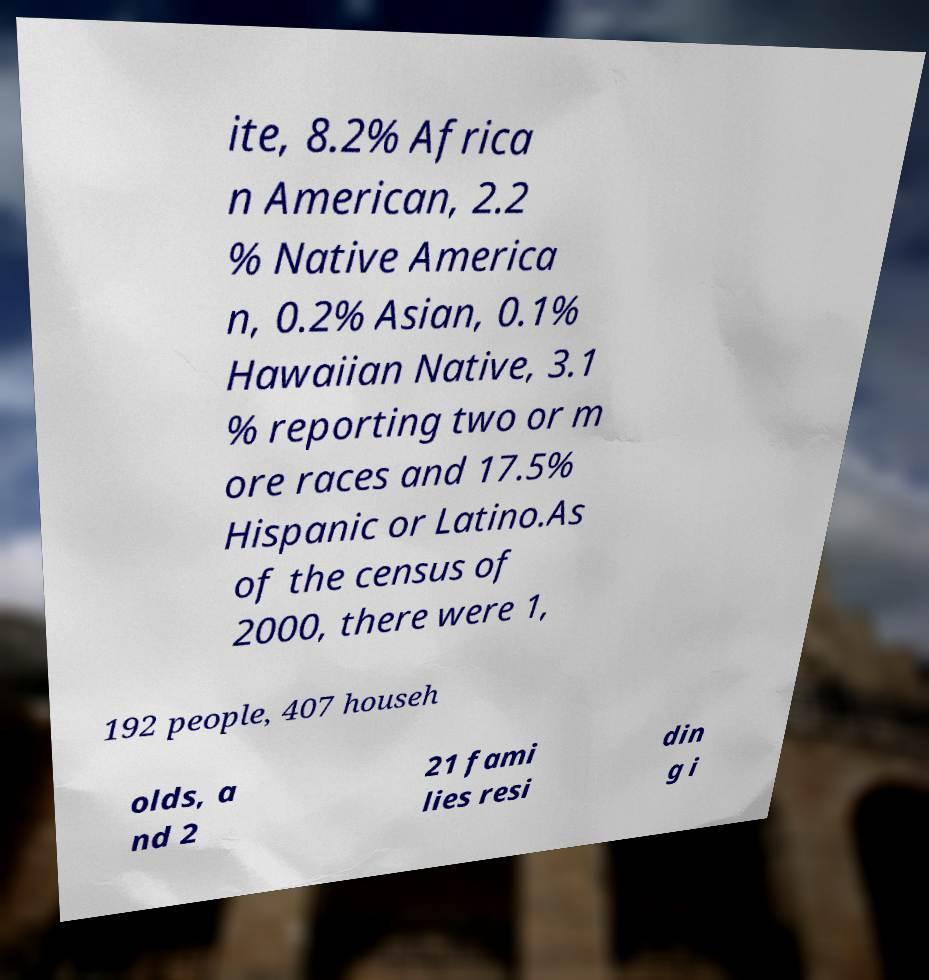Could you assist in decoding the text presented in this image and type it out clearly? ite, 8.2% Africa n American, 2.2 % Native America n, 0.2% Asian, 0.1% Hawaiian Native, 3.1 % reporting two or m ore races and 17.5% Hispanic or Latino.As of the census of 2000, there were 1, 192 people, 407 househ olds, a nd 2 21 fami lies resi din g i 